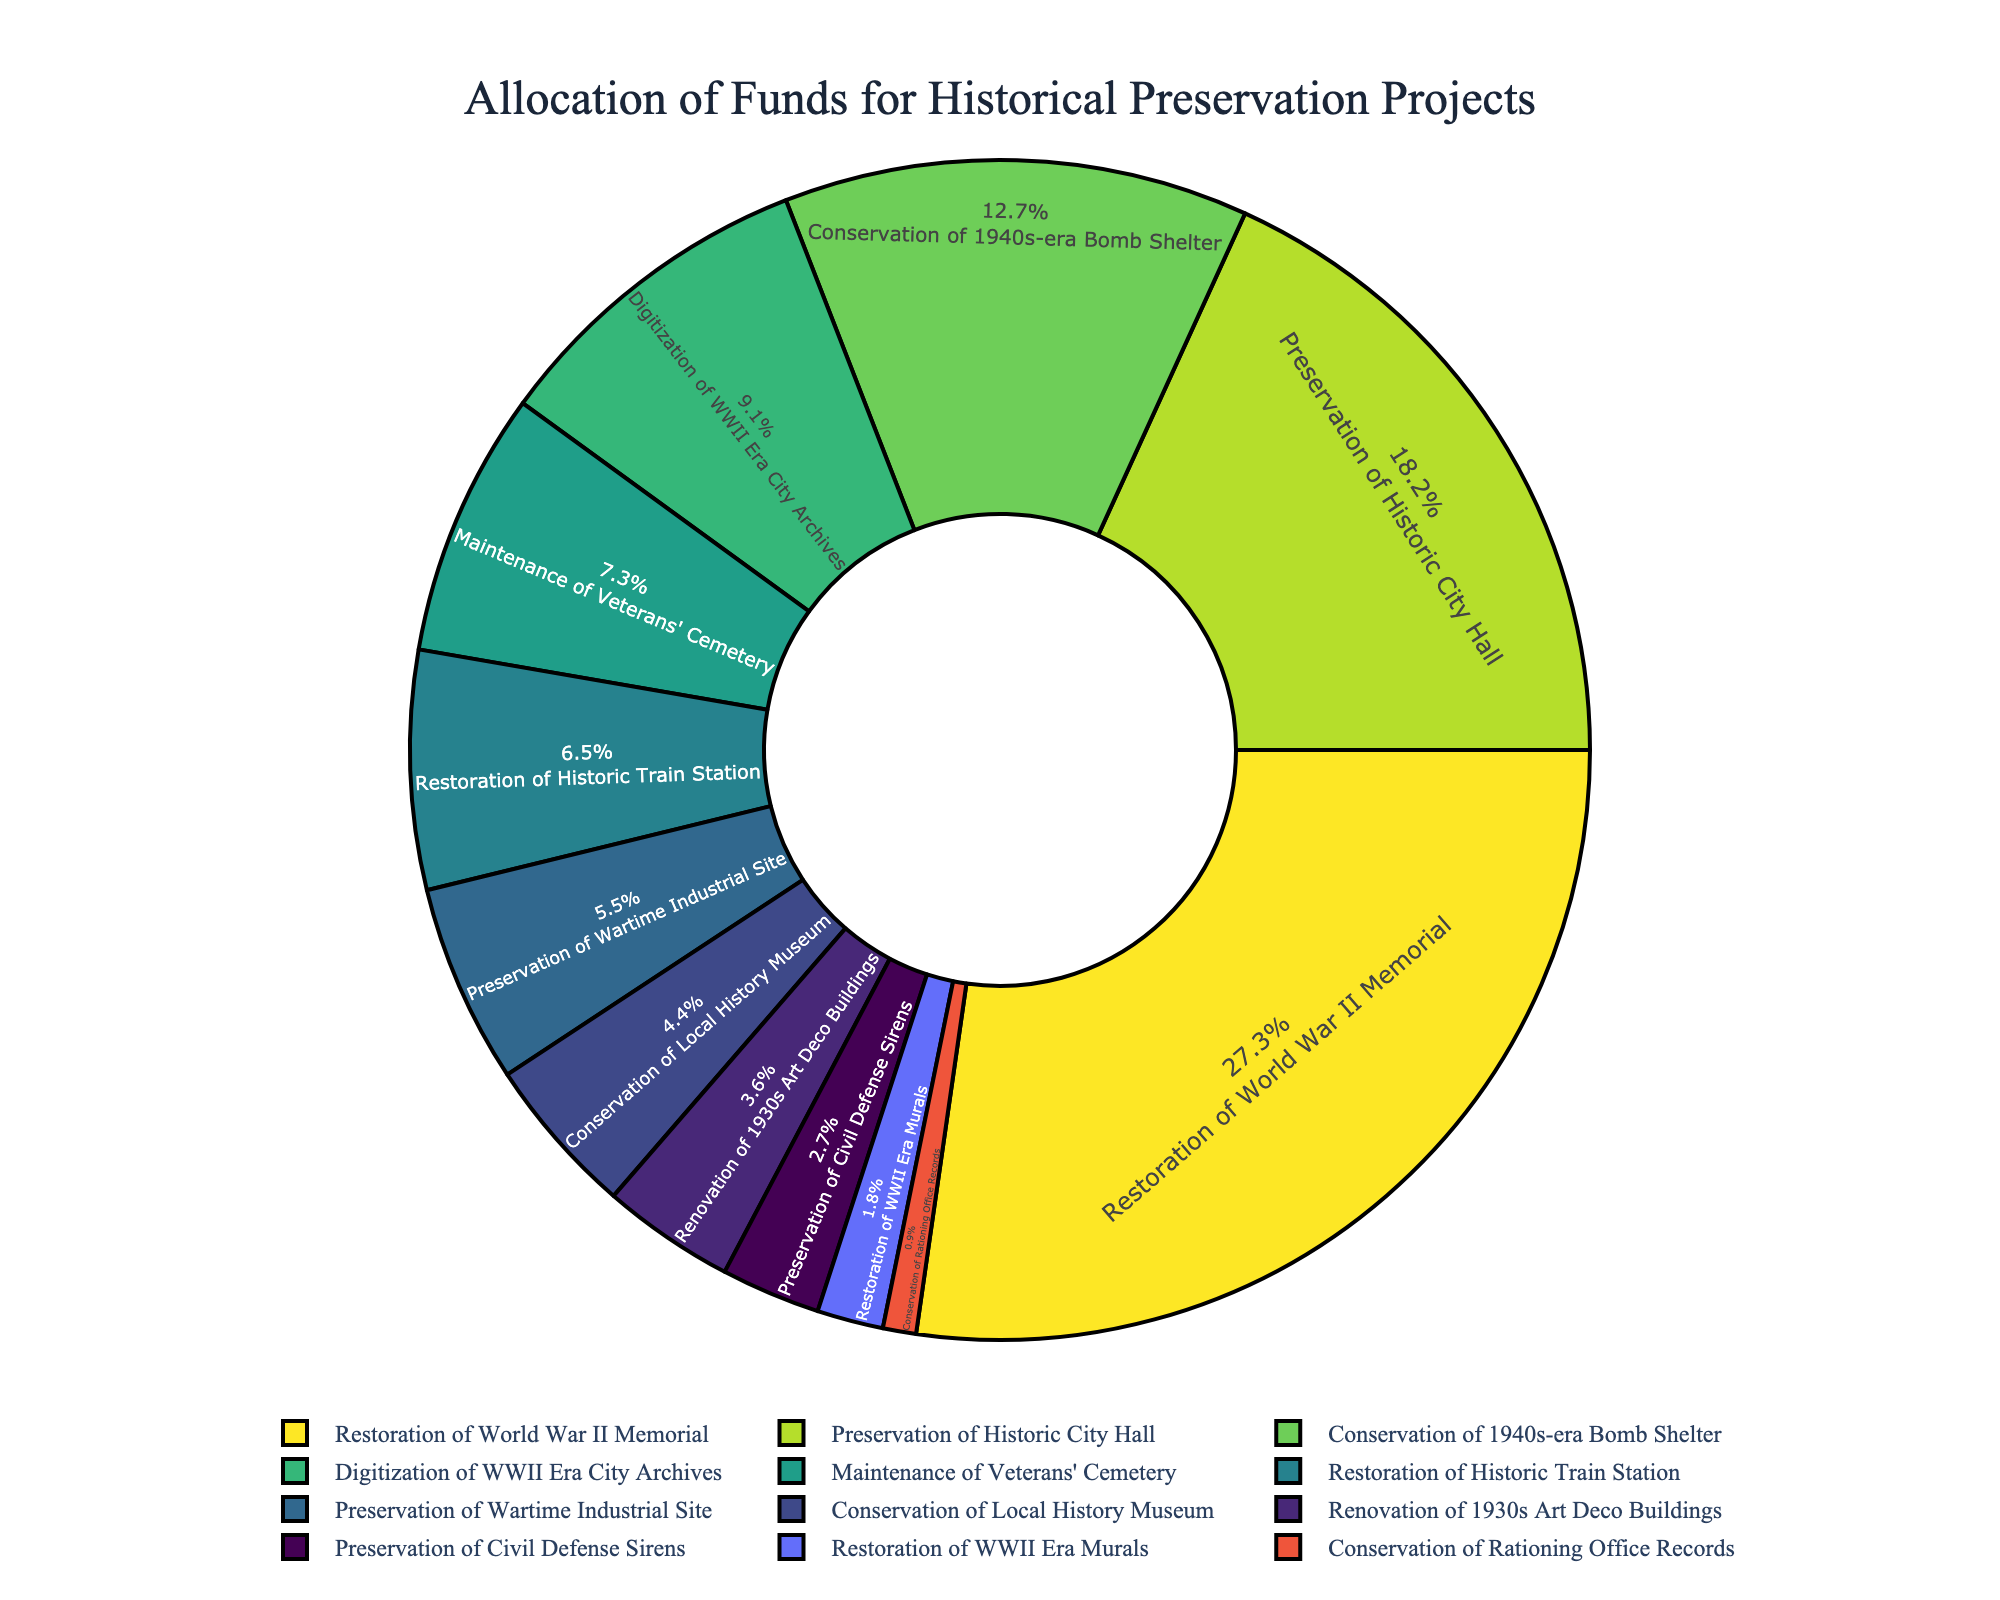What's the largest allocation of funds? The largest allocation of funds is directly visible by identifying the largest segment in the pie chart. The largest segment corresponds to the Restoration of World War II Memorial.
Answer: Restoration of World War II Memorial What percentage of the total funds is allocated to the Preservation of Historic City Hall and Conservation of 1940s-era Bomb Shelter combined? First, identify the individual percentages for Preservation of Historic City Hall and Conservation of 1940s-era Bomb Shelter. Sum these percentages to get the combined total.
Answer: (20.83% + 14.58%) = 35.41% Which project received the least amount of funding? The smallest segment in the pie chart will represent the project with the least funding. This segment corresponds to the Conservation of Rationing Office Records.
Answer: Conservation of Rationing Office Records How does the funding for Maintenance of Veterans' Cemetery compare to that for the Renovation of 1930s Art Deco Buildings? Locate both segments in the pie chart. The Maintenance of Veterans' Cemetery segment is larger than the Renovation of 1930s Art Deco Buildings segment, indicating it received more funds.
Answer: Maintenance of Veterans' Cemetery received more funds What is the total allocation for all projects specifically related to World War II? Identify all projects related to World War II (Restoration of World War II Memorial, Digitization of WWII Era City Archives, Preservation of Civil Defense Sirens, Restoration of WWII Era Murals, Conservation of Rationing Office Records) and sum their allocations.
Answer: ($750,000 + $250,000 + $75,000 + $50,000 + $25,000) = $1,150,000 What is the difference in funding between the Restoration of the Historic Train Station and Preservation of Wartime Industrial Site? Find the funding amounts for both projects. Subtract the lesser amount (Preservation of Wartime Industrial Site) from the greater amount (Restoration of Historic Train Station).
Answer: ($180,000 - $150,000) = $30,000 How many projects received more than $200,000 in funding? Count the segments in the pie chart where the funding amount exceeds $200,000. These are the Restoration of World War II Memorial, Preservation of Historic City Hall, Conservation of 1940s-era Bomb Shelter, and Digitization of WWII Era City Archives.
Answer: 4 projects What color is associated with the project that received $120,000 in funding? Identify the segment representing the Conservation of Local History Museum, which received $120,000. Determine its color based on the chart, which in this case is part of the Viridis palette.
Answer: The segment for Conservation of Local History Museum is represented by a purple color What fraction of the total funds does the Restoration of Historic Train Station represent? Convert the funding for the Restoration of Historic Train Station ($180,000) into a fraction of the total funding (sum of all fundings, $2,850,000). Simplify this fraction if possible.
Answer: ($180,000 / $2,850,000) = 1/15 (approximately, simplified) What is the ratio of funding between Preservation of Historic City Hall and Maintenance of Veterans' Cemetery? Identify the funding amounts for both projects: Preservation of Historic City Hall ($500,000) and Maintenance of Veterans' Cemetery ($200,000). Express their ratio in simplest form.
Answer: 5:2 